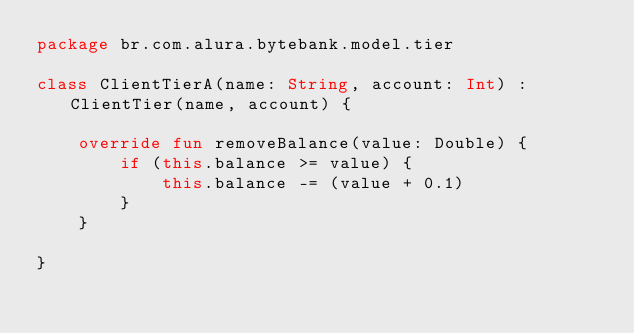<code> <loc_0><loc_0><loc_500><loc_500><_Kotlin_>package br.com.alura.bytebank.model.tier

class ClientTierA(name: String, account: Int) : ClientTier(name, account) {

    override fun removeBalance(value: Double) {
        if (this.balance >= value) {
            this.balance -= (value + 0.1)
        }
    }

}</code> 